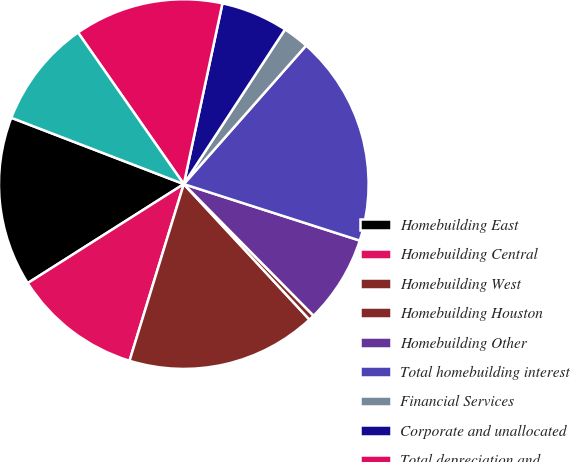<chart> <loc_0><loc_0><loc_500><loc_500><pie_chart><fcel>Homebuilding East<fcel>Homebuilding Central<fcel>Homebuilding West<fcel>Homebuilding Houston<fcel>Homebuilding Other<fcel>Total homebuilding interest<fcel>Financial Services<fcel>Corporate and unallocated<fcel>Total depreciation and<fcel>Total net additions<nl><fcel>14.84%<fcel>11.26%<fcel>16.64%<fcel>0.49%<fcel>7.67%<fcel>18.43%<fcel>2.29%<fcel>5.87%<fcel>13.05%<fcel>9.46%<nl></chart> 